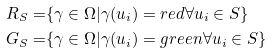Convert formula to latex. <formula><loc_0><loc_0><loc_500><loc_500>R _ { S } = & \{ \gamma \in \Omega | \gamma ( u _ { i } ) = r e d \forall u _ { i } \in S \} \\ G _ { S } = & \{ \gamma \in \Omega | \gamma ( u _ { i } ) = g r e e n \forall u _ { i } \in S \}</formula> 